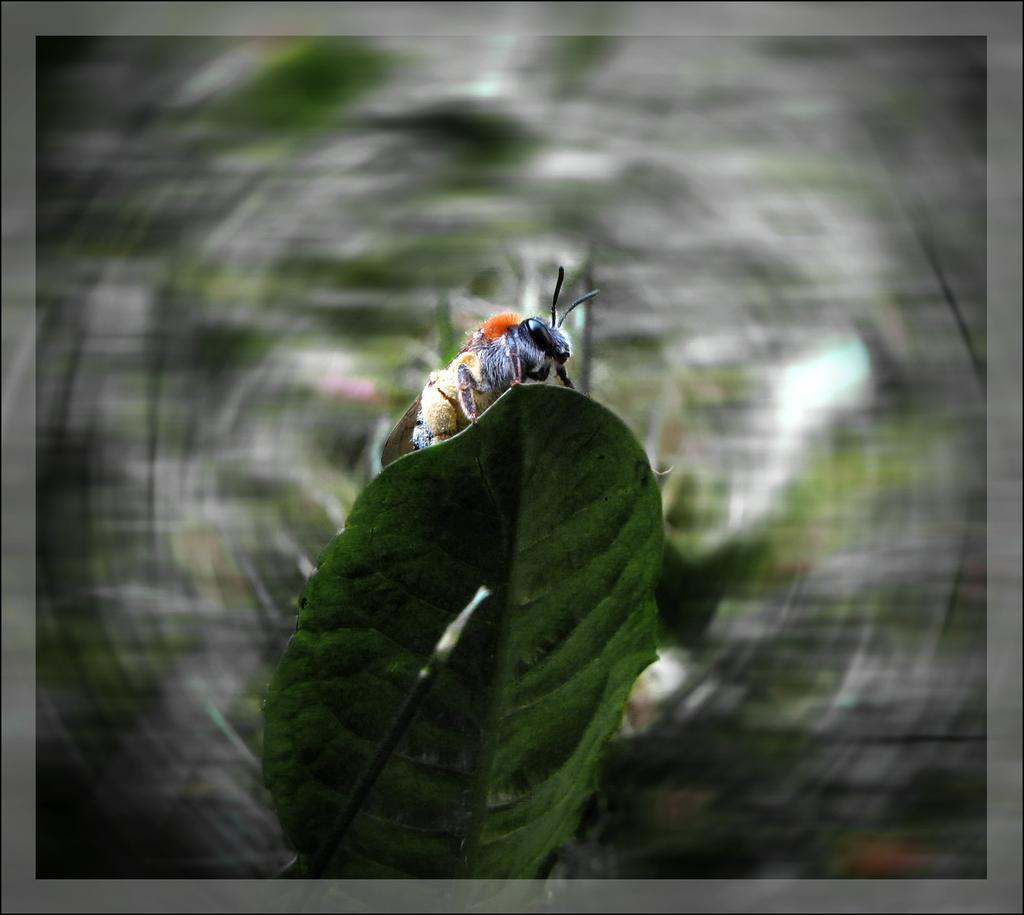Can you describe this image briefly? In this image we can see one insect on the green leaf, one object in front of the green leaf, the background is blurred and there is a gray border. 